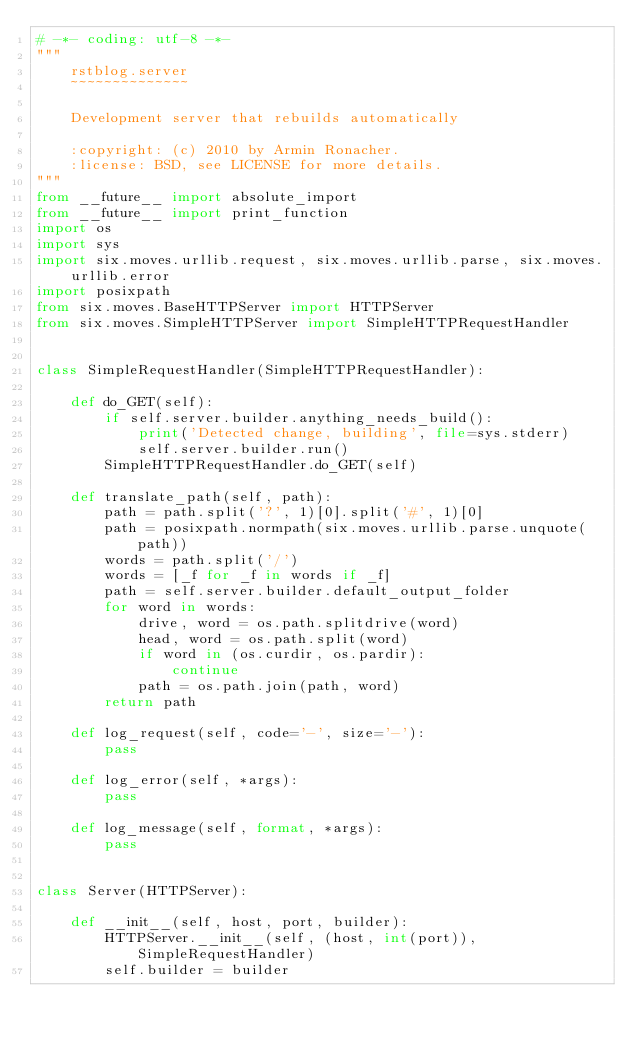<code> <loc_0><loc_0><loc_500><loc_500><_Python_># -*- coding: utf-8 -*-
"""
    rstblog.server
    ~~~~~~~~~~~~~~

    Development server that rebuilds automatically

    :copyright: (c) 2010 by Armin Ronacher.
    :license: BSD, see LICENSE for more details.
"""
from __future__ import absolute_import
from __future__ import print_function
import os
import sys
import six.moves.urllib.request, six.moves.urllib.parse, six.moves.urllib.error
import posixpath
from six.moves.BaseHTTPServer import HTTPServer
from six.moves.SimpleHTTPServer import SimpleHTTPRequestHandler


class SimpleRequestHandler(SimpleHTTPRequestHandler):

    def do_GET(self):
        if self.server.builder.anything_needs_build():
            print('Detected change, building', file=sys.stderr)
            self.server.builder.run()
        SimpleHTTPRequestHandler.do_GET(self)

    def translate_path(self, path):
        path = path.split('?', 1)[0].split('#', 1)[0]
        path = posixpath.normpath(six.moves.urllib.parse.unquote(path))
        words = path.split('/')
        words = [_f for _f in words if _f]
        path = self.server.builder.default_output_folder
        for word in words:
            drive, word = os.path.splitdrive(word)
            head, word = os.path.split(word)
            if word in (os.curdir, os.pardir):
                continue
            path = os.path.join(path, word)
        return path

    def log_request(self, code='-', size='-'):
        pass

    def log_error(self, *args):
        pass

    def log_message(self, format, *args):
        pass


class Server(HTTPServer):

    def __init__(self, host, port, builder):
        HTTPServer.__init__(self, (host, int(port)), SimpleRequestHandler)
        self.builder = builder
</code> 